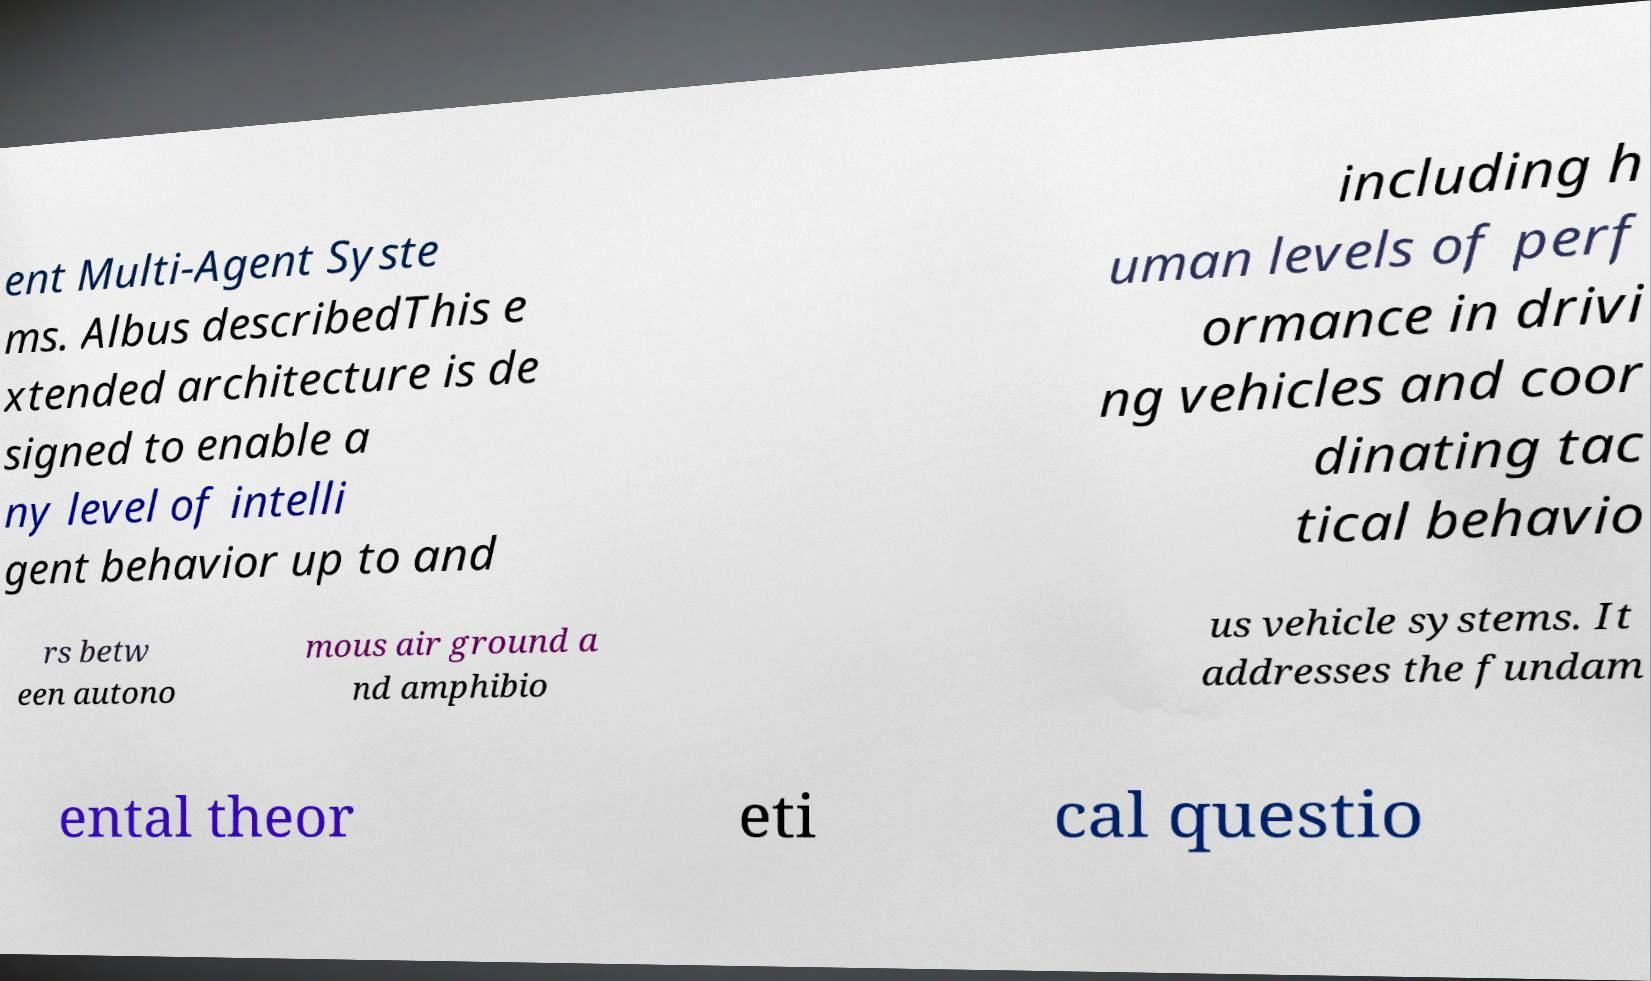Please read and relay the text visible in this image. What does it say? ent Multi-Agent Syste ms. Albus describedThis e xtended architecture is de signed to enable a ny level of intelli gent behavior up to and including h uman levels of perf ormance in drivi ng vehicles and coor dinating tac tical behavio rs betw een autono mous air ground a nd amphibio us vehicle systems. It addresses the fundam ental theor eti cal questio 